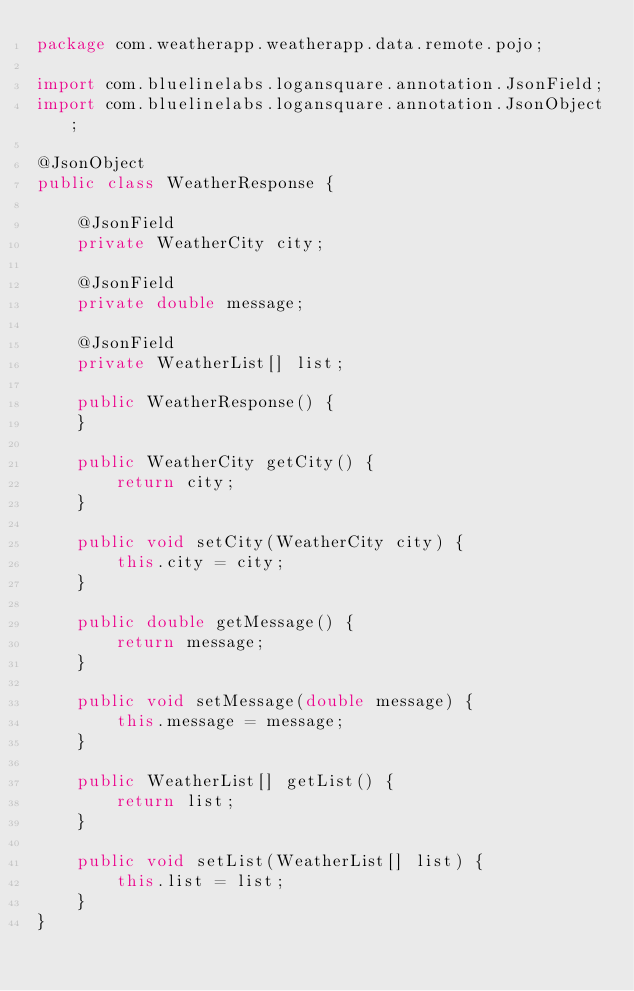Convert code to text. <code><loc_0><loc_0><loc_500><loc_500><_Java_>package com.weatherapp.weatherapp.data.remote.pojo;

import com.bluelinelabs.logansquare.annotation.JsonField;
import com.bluelinelabs.logansquare.annotation.JsonObject;

@JsonObject
public class WeatherResponse {

    @JsonField
    private WeatherCity city;

    @JsonField
    private double message;

    @JsonField
    private WeatherList[] list;

    public WeatherResponse() {
    }

    public WeatherCity getCity() {
        return city;
    }

    public void setCity(WeatherCity city) {
        this.city = city;
    }

    public double getMessage() {
        return message;
    }

    public void setMessage(double message) {
        this.message = message;
    }

    public WeatherList[] getList() {
        return list;
    }

    public void setList(WeatherList[] list) {
        this.list = list;
    }
}
</code> 